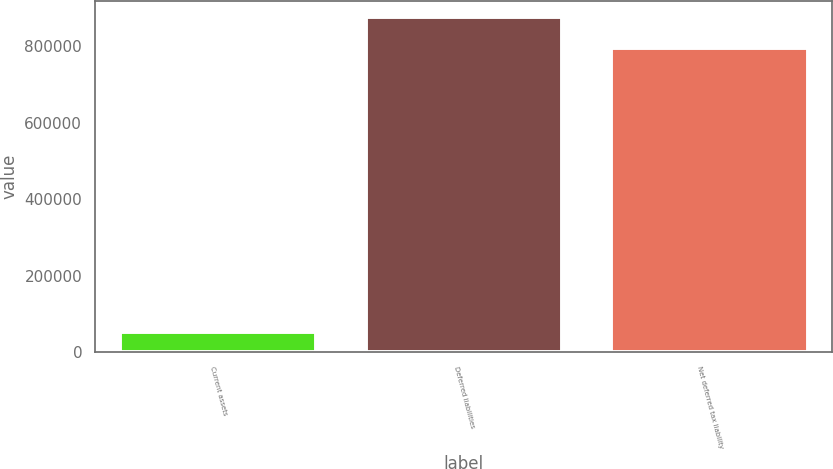Convert chart. <chart><loc_0><loc_0><loc_500><loc_500><bar_chart><fcel>Current assets<fcel>Deferred liabilities<fcel>Net deferred tax liability<nl><fcel>53794<fcel>875219<fcel>795654<nl></chart> 